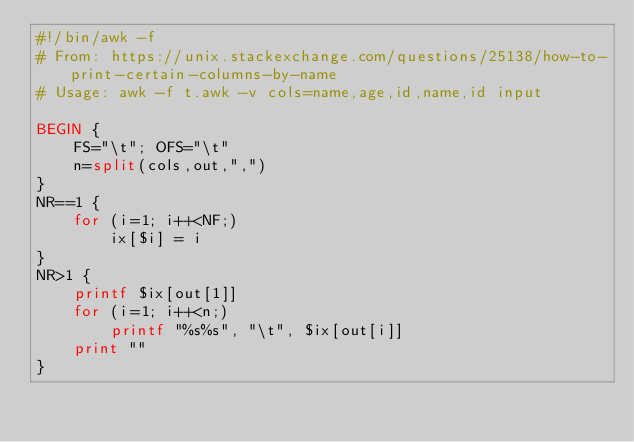<code> <loc_0><loc_0><loc_500><loc_500><_Awk_>#!/bin/awk -f
# From: https://unix.stackexchange.com/questions/25138/how-to-print-certain-columns-by-name
# Usage: awk -f t.awk -v cols=name,age,id,name,id input

BEGIN {
    FS="\t"; OFS="\t"
    n=split(cols,out,",")
}
NR==1 {
    for (i=1; i++<NF;)
        ix[$i] = i
}
NR>1 {
    printf $ix[out[1]]
    for (i=1; i++<n;)
        printf "%s%s", "\t", $ix[out[i]]
    print ""
}
</code> 